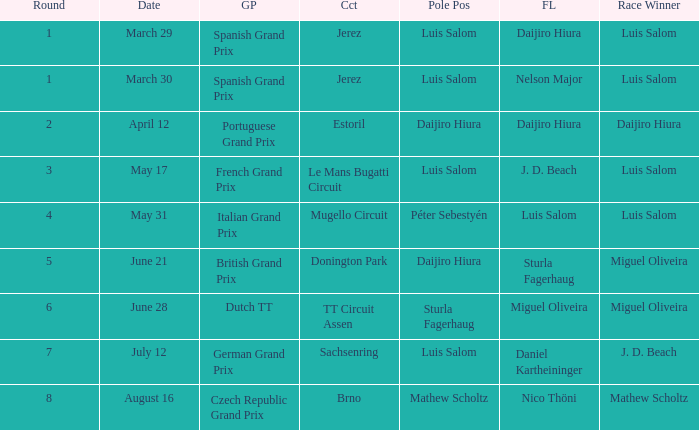Could you parse the entire table as a dict? {'header': ['Round', 'Date', 'GP', 'Cct', 'Pole Pos', 'FL', 'Race Winner'], 'rows': [['1', 'March 29', 'Spanish Grand Prix', 'Jerez', 'Luis Salom', 'Daijiro Hiura', 'Luis Salom'], ['1', 'March 30', 'Spanish Grand Prix', 'Jerez', 'Luis Salom', 'Nelson Major', 'Luis Salom'], ['2', 'April 12', 'Portuguese Grand Prix', 'Estoril', 'Daijiro Hiura', 'Daijiro Hiura', 'Daijiro Hiura'], ['3', 'May 17', 'French Grand Prix', 'Le Mans Bugatti Circuit', 'Luis Salom', 'J. D. Beach', 'Luis Salom'], ['4', 'May 31', 'Italian Grand Prix', 'Mugello Circuit', 'Péter Sebestyén', 'Luis Salom', 'Luis Salom'], ['5', 'June 21', 'British Grand Prix', 'Donington Park', 'Daijiro Hiura', 'Sturla Fagerhaug', 'Miguel Oliveira'], ['6', 'June 28', 'Dutch TT', 'TT Circuit Assen', 'Sturla Fagerhaug', 'Miguel Oliveira', 'Miguel Oliveira'], ['7', 'July 12', 'German Grand Prix', 'Sachsenring', 'Luis Salom', 'Daniel Kartheininger', 'J. D. Beach'], ['8', 'August 16', 'Czech Republic Grand Prix', 'Brno', 'Mathew Scholtz', 'Nico Thöni', 'Mathew Scholtz']]} Luis Salom had the fastest lap on which circuits?  Mugello Circuit. 